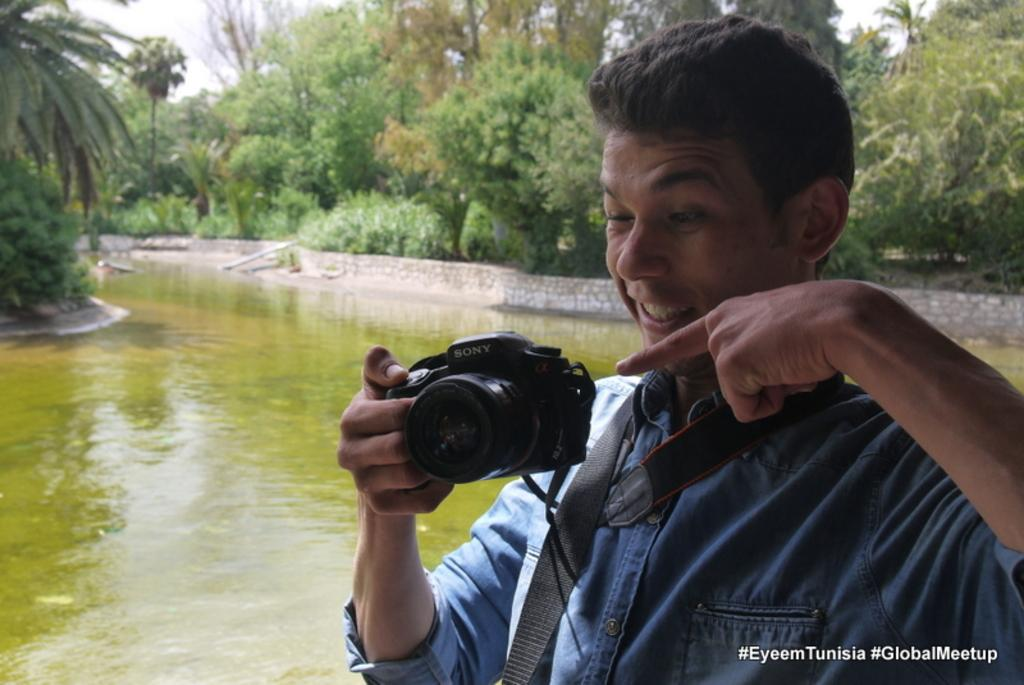What is the person in the image doing? The person is holding a camera in the image. Where is the person located in the image? The person is on the right side of the image. What can be seen in the background of the image? There is water and trees visible in the background of the image. What text is written on the right side of the image? The text "Eyeem tumisea global meetup" is written on the right side of the image. Can you see any caves in the image? There are no caves visible in the image. What type of journey is the person embarking on in the image? The image does not provide any information about the person's journey, as it only shows them holding a camera. 